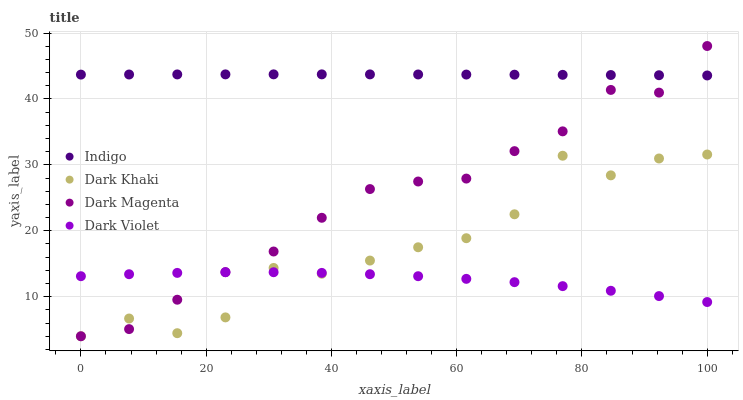Does Dark Violet have the minimum area under the curve?
Answer yes or no. Yes. Does Indigo have the maximum area under the curve?
Answer yes or no. Yes. Does Dark Magenta have the minimum area under the curve?
Answer yes or no. No. Does Dark Magenta have the maximum area under the curve?
Answer yes or no. No. Is Indigo the smoothest?
Answer yes or no. Yes. Is Dark Khaki the roughest?
Answer yes or no. Yes. Is Dark Magenta the smoothest?
Answer yes or no. No. Is Dark Magenta the roughest?
Answer yes or no. No. Does Dark Khaki have the lowest value?
Answer yes or no. Yes. Does Indigo have the lowest value?
Answer yes or no. No. Does Dark Magenta have the highest value?
Answer yes or no. Yes. Does Indigo have the highest value?
Answer yes or no. No. Is Dark Violet less than Indigo?
Answer yes or no. Yes. Is Indigo greater than Dark Khaki?
Answer yes or no. Yes. Does Indigo intersect Dark Magenta?
Answer yes or no. Yes. Is Indigo less than Dark Magenta?
Answer yes or no. No. Is Indigo greater than Dark Magenta?
Answer yes or no. No. Does Dark Violet intersect Indigo?
Answer yes or no. No. 